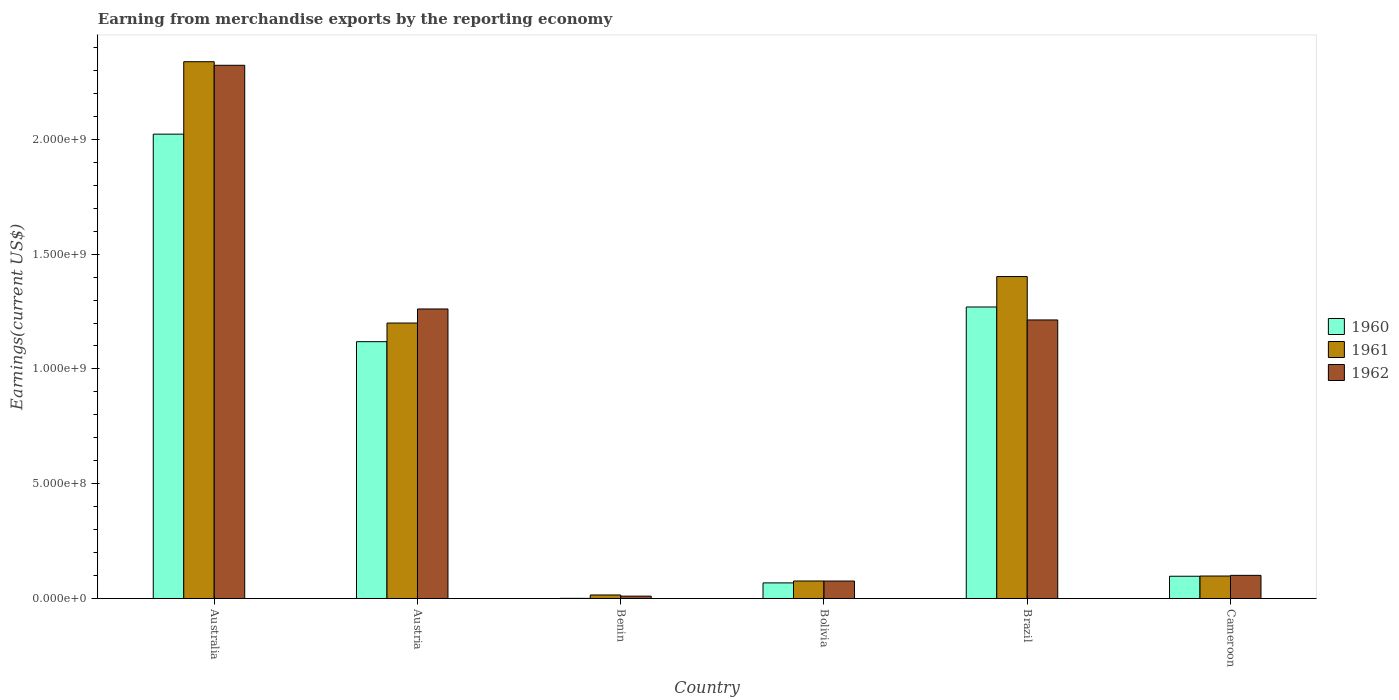How many different coloured bars are there?
Make the answer very short. 3. How many groups of bars are there?
Your answer should be compact. 6. Are the number of bars per tick equal to the number of legend labels?
Give a very brief answer. Yes. How many bars are there on the 5th tick from the left?
Keep it short and to the point. 3. How many bars are there on the 4th tick from the right?
Your answer should be compact. 3. What is the label of the 2nd group of bars from the left?
Your answer should be very brief. Austria. In how many cases, is the number of bars for a given country not equal to the number of legend labels?
Offer a terse response. 0. What is the amount earned from merchandise exports in 1961 in Benin?
Your response must be concise. 1.53e+07. Across all countries, what is the maximum amount earned from merchandise exports in 1962?
Offer a very short reply. 2.32e+09. Across all countries, what is the minimum amount earned from merchandise exports in 1962?
Keep it short and to the point. 1.02e+07. In which country was the amount earned from merchandise exports in 1962 minimum?
Ensure brevity in your answer.  Benin. What is the total amount earned from merchandise exports in 1960 in the graph?
Provide a succinct answer. 4.58e+09. What is the difference between the amount earned from merchandise exports in 1960 in Australia and that in Bolivia?
Your answer should be compact. 1.96e+09. What is the difference between the amount earned from merchandise exports in 1961 in Brazil and the amount earned from merchandise exports in 1960 in Australia?
Offer a very short reply. -6.20e+08. What is the average amount earned from merchandise exports in 1961 per country?
Give a very brief answer. 8.55e+08. What is the difference between the amount earned from merchandise exports of/in 1962 and amount earned from merchandise exports of/in 1960 in Cameroon?
Provide a succinct answer. 3.90e+06. What is the ratio of the amount earned from merchandise exports in 1960 in Benin to that in Brazil?
Your answer should be compact. 0. Is the difference between the amount earned from merchandise exports in 1962 in Austria and Brazil greater than the difference between the amount earned from merchandise exports in 1960 in Austria and Brazil?
Offer a very short reply. Yes. What is the difference between the highest and the second highest amount earned from merchandise exports in 1962?
Your answer should be compact. 1.06e+09. What is the difference between the highest and the lowest amount earned from merchandise exports in 1961?
Ensure brevity in your answer.  2.32e+09. In how many countries, is the amount earned from merchandise exports in 1960 greater than the average amount earned from merchandise exports in 1960 taken over all countries?
Make the answer very short. 3. Is the sum of the amount earned from merchandise exports in 1960 in Austria and Benin greater than the maximum amount earned from merchandise exports in 1962 across all countries?
Ensure brevity in your answer.  No. What does the 1st bar from the left in Bolivia represents?
Your answer should be compact. 1960. Is it the case that in every country, the sum of the amount earned from merchandise exports in 1962 and amount earned from merchandise exports in 1960 is greater than the amount earned from merchandise exports in 1961?
Provide a short and direct response. No. How many bars are there?
Give a very brief answer. 18. How many countries are there in the graph?
Give a very brief answer. 6. What is the difference between two consecutive major ticks on the Y-axis?
Provide a short and direct response. 5.00e+08. What is the title of the graph?
Keep it short and to the point. Earning from merchandise exports by the reporting economy. Does "1995" appear as one of the legend labels in the graph?
Your answer should be compact. No. What is the label or title of the Y-axis?
Your answer should be compact. Earnings(current US$). What is the Earnings(current US$) in 1960 in Australia?
Make the answer very short. 2.02e+09. What is the Earnings(current US$) in 1961 in Australia?
Offer a terse response. 2.34e+09. What is the Earnings(current US$) of 1962 in Australia?
Keep it short and to the point. 2.32e+09. What is the Earnings(current US$) of 1960 in Austria?
Provide a succinct answer. 1.12e+09. What is the Earnings(current US$) of 1961 in Austria?
Provide a short and direct response. 1.20e+09. What is the Earnings(current US$) of 1962 in Austria?
Offer a very short reply. 1.26e+09. What is the Earnings(current US$) in 1961 in Benin?
Make the answer very short. 1.53e+07. What is the Earnings(current US$) of 1962 in Benin?
Make the answer very short. 1.02e+07. What is the Earnings(current US$) in 1960 in Bolivia?
Make the answer very short. 6.79e+07. What is the Earnings(current US$) in 1961 in Bolivia?
Offer a very short reply. 7.62e+07. What is the Earnings(current US$) in 1962 in Bolivia?
Your response must be concise. 7.60e+07. What is the Earnings(current US$) in 1960 in Brazil?
Keep it short and to the point. 1.27e+09. What is the Earnings(current US$) in 1961 in Brazil?
Provide a succinct answer. 1.40e+09. What is the Earnings(current US$) of 1962 in Brazil?
Make the answer very short. 1.21e+09. What is the Earnings(current US$) of 1960 in Cameroon?
Offer a very short reply. 9.69e+07. What is the Earnings(current US$) of 1961 in Cameroon?
Offer a very short reply. 9.79e+07. What is the Earnings(current US$) of 1962 in Cameroon?
Your answer should be compact. 1.01e+08. Across all countries, what is the maximum Earnings(current US$) of 1960?
Offer a terse response. 2.02e+09. Across all countries, what is the maximum Earnings(current US$) of 1961?
Keep it short and to the point. 2.34e+09. Across all countries, what is the maximum Earnings(current US$) of 1962?
Provide a short and direct response. 2.32e+09. Across all countries, what is the minimum Earnings(current US$) of 1960?
Your answer should be compact. 5.00e+05. Across all countries, what is the minimum Earnings(current US$) of 1961?
Offer a terse response. 1.53e+07. Across all countries, what is the minimum Earnings(current US$) in 1962?
Provide a short and direct response. 1.02e+07. What is the total Earnings(current US$) of 1960 in the graph?
Keep it short and to the point. 4.58e+09. What is the total Earnings(current US$) of 1961 in the graph?
Your answer should be very brief. 5.13e+09. What is the total Earnings(current US$) of 1962 in the graph?
Provide a succinct answer. 4.98e+09. What is the difference between the Earnings(current US$) of 1960 in Australia and that in Austria?
Make the answer very short. 9.04e+08. What is the difference between the Earnings(current US$) in 1961 in Australia and that in Austria?
Your answer should be very brief. 1.14e+09. What is the difference between the Earnings(current US$) in 1962 in Australia and that in Austria?
Keep it short and to the point. 1.06e+09. What is the difference between the Earnings(current US$) in 1960 in Australia and that in Benin?
Give a very brief answer. 2.02e+09. What is the difference between the Earnings(current US$) of 1961 in Australia and that in Benin?
Keep it short and to the point. 2.32e+09. What is the difference between the Earnings(current US$) in 1962 in Australia and that in Benin?
Make the answer very short. 2.31e+09. What is the difference between the Earnings(current US$) in 1960 in Australia and that in Bolivia?
Provide a succinct answer. 1.96e+09. What is the difference between the Earnings(current US$) in 1961 in Australia and that in Bolivia?
Your response must be concise. 2.26e+09. What is the difference between the Earnings(current US$) of 1962 in Australia and that in Bolivia?
Offer a very short reply. 2.25e+09. What is the difference between the Earnings(current US$) in 1960 in Australia and that in Brazil?
Make the answer very short. 7.53e+08. What is the difference between the Earnings(current US$) in 1961 in Australia and that in Brazil?
Offer a very short reply. 9.36e+08. What is the difference between the Earnings(current US$) in 1962 in Australia and that in Brazil?
Your answer should be very brief. 1.11e+09. What is the difference between the Earnings(current US$) of 1960 in Australia and that in Cameroon?
Your response must be concise. 1.93e+09. What is the difference between the Earnings(current US$) of 1961 in Australia and that in Cameroon?
Give a very brief answer. 2.24e+09. What is the difference between the Earnings(current US$) in 1962 in Australia and that in Cameroon?
Ensure brevity in your answer.  2.22e+09. What is the difference between the Earnings(current US$) in 1960 in Austria and that in Benin?
Keep it short and to the point. 1.12e+09. What is the difference between the Earnings(current US$) of 1961 in Austria and that in Benin?
Ensure brevity in your answer.  1.18e+09. What is the difference between the Earnings(current US$) in 1962 in Austria and that in Benin?
Your answer should be compact. 1.25e+09. What is the difference between the Earnings(current US$) of 1960 in Austria and that in Bolivia?
Give a very brief answer. 1.05e+09. What is the difference between the Earnings(current US$) of 1961 in Austria and that in Bolivia?
Your response must be concise. 1.12e+09. What is the difference between the Earnings(current US$) in 1962 in Austria and that in Bolivia?
Keep it short and to the point. 1.19e+09. What is the difference between the Earnings(current US$) of 1960 in Austria and that in Brazil?
Provide a succinct answer. -1.51e+08. What is the difference between the Earnings(current US$) of 1961 in Austria and that in Brazil?
Give a very brief answer. -2.02e+08. What is the difference between the Earnings(current US$) of 1962 in Austria and that in Brazil?
Provide a short and direct response. 4.78e+07. What is the difference between the Earnings(current US$) of 1960 in Austria and that in Cameroon?
Your answer should be compact. 1.02e+09. What is the difference between the Earnings(current US$) in 1961 in Austria and that in Cameroon?
Offer a terse response. 1.10e+09. What is the difference between the Earnings(current US$) of 1962 in Austria and that in Cameroon?
Make the answer very short. 1.16e+09. What is the difference between the Earnings(current US$) in 1960 in Benin and that in Bolivia?
Offer a very short reply. -6.74e+07. What is the difference between the Earnings(current US$) of 1961 in Benin and that in Bolivia?
Provide a succinct answer. -6.09e+07. What is the difference between the Earnings(current US$) in 1962 in Benin and that in Bolivia?
Give a very brief answer. -6.58e+07. What is the difference between the Earnings(current US$) in 1960 in Benin and that in Brazil?
Offer a very short reply. -1.27e+09. What is the difference between the Earnings(current US$) of 1961 in Benin and that in Brazil?
Ensure brevity in your answer.  -1.39e+09. What is the difference between the Earnings(current US$) in 1962 in Benin and that in Brazil?
Provide a succinct answer. -1.20e+09. What is the difference between the Earnings(current US$) in 1960 in Benin and that in Cameroon?
Your answer should be compact. -9.64e+07. What is the difference between the Earnings(current US$) of 1961 in Benin and that in Cameroon?
Provide a succinct answer. -8.26e+07. What is the difference between the Earnings(current US$) in 1962 in Benin and that in Cameroon?
Your response must be concise. -9.06e+07. What is the difference between the Earnings(current US$) in 1960 in Bolivia and that in Brazil?
Your answer should be compact. -1.20e+09. What is the difference between the Earnings(current US$) of 1961 in Bolivia and that in Brazil?
Offer a very short reply. -1.33e+09. What is the difference between the Earnings(current US$) in 1962 in Bolivia and that in Brazil?
Keep it short and to the point. -1.14e+09. What is the difference between the Earnings(current US$) of 1960 in Bolivia and that in Cameroon?
Give a very brief answer. -2.90e+07. What is the difference between the Earnings(current US$) of 1961 in Bolivia and that in Cameroon?
Offer a terse response. -2.17e+07. What is the difference between the Earnings(current US$) of 1962 in Bolivia and that in Cameroon?
Ensure brevity in your answer.  -2.48e+07. What is the difference between the Earnings(current US$) in 1960 in Brazil and that in Cameroon?
Provide a succinct answer. 1.17e+09. What is the difference between the Earnings(current US$) of 1961 in Brazil and that in Cameroon?
Ensure brevity in your answer.  1.30e+09. What is the difference between the Earnings(current US$) of 1962 in Brazil and that in Cameroon?
Ensure brevity in your answer.  1.11e+09. What is the difference between the Earnings(current US$) of 1960 in Australia and the Earnings(current US$) of 1961 in Austria?
Your answer should be very brief. 8.23e+08. What is the difference between the Earnings(current US$) in 1960 in Australia and the Earnings(current US$) in 1962 in Austria?
Provide a short and direct response. 7.62e+08. What is the difference between the Earnings(current US$) of 1961 in Australia and the Earnings(current US$) of 1962 in Austria?
Offer a very short reply. 1.08e+09. What is the difference between the Earnings(current US$) of 1960 in Australia and the Earnings(current US$) of 1961 in Benin?
Keep it short and to the point. 2.01e+09. What is the difference between the Earnings(current US$) in 1960 in Australia and the Earnings(current US$) in 1962 in Benin?
Provide a short and direct response. 2.01e+09. What is the difference between the Earnings(current US$) in 1961 in Australia and the Earnings(current US$) in 1962 in Benin?
Provide a succinct answer. 2.33e+09. What is the difference between the Earnings(current US$) in 1960 in Australia and the Earnings(current US$) in 1961 in Bolivia?
Make the answer very short. 1.95e+09. What is the difference between the Earnings(current US$) of 1960 in Australia and the Earnings(current US$) of 1962 in Bolivia?
Your answer should be compact. 1.95e+09. What is the difference between the Earnings(current US$) of 1961 in Australia and the Earnings(current US$) of 1962 in Bolivia?
Provide a short and direct response. 2.26e+09. What is the difference between the Earnings(current US$) of 1960 in Australia and the Earnings(current US$) of 1961 in Brazil?
Make the answer very short. 6.20e+08. What is the difference between the Earnings(current US$) in 1960 in Australia and the Earnings(current US$) in 1962 in Brazil?
Your answer should be compact. 8.09e+08. What is the difference between the Earnings(current US$) in 1961 in Australia and the Earnings(current US$) in 1962 in Brazil?
Provide a short and direct response. 1.12e+09. What is the difference between the Earnings(current US$) of 1960 in Australia and the Earnings(current US$) of 1961 in Cameroon?
Ensure brevity in your answer.  1.92e+09. What is the difference between the Earnings(current US$) in 1960 in Australia and the Earnings(current US$) in 1962 in Cameroon?
Keep it short and to the point. 1.92e+09. What is the difference between the Earnings(current US$) in 1961 in Australia and the Earnings(current US$) in 1962 in Cameroon?
Offer a very short reply. 2.24e+09. What is the difference between the Earnings(current US$) in 1960 in Austria and the Earnings(current US$) in 1961 in Benin?
Provide a short and direct response. 1.10e+09. What is the difference between the Earnings(current US$) of 1960 in Austria and the Earnings(current US$) of 1962 in Benin?
Your response must be concise. 1.11e+09. What is the difference between the Earnings(current US$) of 1961 in Austria and the Earnings(current US$) of 1962 in Benin?
Provide a short and direct response. 1.19e+09. What is the difference between the Earnings(current US$) in 1960 in Austria and the Earnings(current US$) in 1961 in Bolivia?
Offer a very short reply. 1.04e+09. What is the difference between the Earnings(current US$) in 1960 in Austria and the Earnings(current US$) in 1962 in Bolivia?
Ensure brevity in your answer.  1.04e+09. What is the difference between the Earnings(current US$) in 1961 in Austria and the Earnings(current US$) in 1962 in Bolivia?
Make the answer very short. 1.12e+09. What is the difference between the Earnings(current US$) of 1960 in Austria and the Earnings(current US$) of 1961 in Brazil?
Offer a terse response. -2.84e+08. What is the difference between the Earnings(current US$) of 1960 in Austria and the Earnings(current US$) of 1962 in Brazil?
Keep it short and to the point. -9.46e+07. What is the difference between the Earnings(current US$) in 1961 in Austria and the Earnings(current US$) in 1962 in Brazil?
Ensure brevity in your answer.  -1.35e+07. What is the difference between the Earnings(current US$) of 1960 in Austria and the Earnings(current US$) of 1961 in Cameroon?
Your answer should be very brief. 1.02e+09. What is the difference between the Earnings(current US$) in 1960 in Austria and the Earnings(current US$) in 1962 in Cameroon?
Offer a very short reply. 1.02e+09. What is the difference between the Earnings(current US$) of 1961 in Austria and the Earnings(current US$) of 1962 in Cameroon?
Provide a succinct answer. 1.10e+09. What is the difference between the Earnings(current US$) in 1960 in Benin and the Earnings(current US$) in 1961 in Bolivia?
Your response must be concise. -7.57e+07. What is the difference between the Earnings(current US$) in 1960 in Benin and the Earnings(current US$) in 1962 in Bolivia?
Provide a short and direct response. -7.55e+07. What is the difference between the Earnings(current US$) of 1961 in Benin and the Earnings(current US$) of 1962 in Bolivia?
Your response must be concise. -6.07e+07. What is the difference between the Earnings(current US$) in 1960 in Benin and the Earnings(current US$) in 1961 in Brazil?
Ensure brevity in your answer.  -1.40e+09. What is the difference between the Earnings(current US$) of 1960 in Benin and the Earnings(current US$) of 1962 in Brazil?
Provide a succinct answer. -1.21e+09. What is the difference between the Earnings(current US$) of 1961 in Benin and the Earnings(current US$) of 1962 in Brazil?
Provide a succinct answer. -1.20e+09. What is the difference between the Earnings(current US$) of 1960 in Benin and the Earnings(current US$) of 1961 in Cameroon?
Make the answer very short. -9.74e+07. What is the difference between the Earnings(current US$) of 1960 in Benin and the Earnings(current US$) of 1962 in Cameroon?
Give a very brief answer. -1.00e+08. What is the difference between the Earnings(current US$) of 1961 in Benin and the Earnings(current US$) of 1962 in Cameroon?
Keep it short and to the point. -8.55e+07. What is the difference between the Earnings(current US$) of 1960 in Bolivia and the Earnings(current US$) of 1961 in Brazil?
Offer a very short reply. -1.33e+09. What is the difference between the Earnings(current US$) in 1960 in Bolivia and the Earnings(current US$) in 1962 in Brazil?
Your answer should be very brief. -1.15e+09. What is the difference between the Earnings(current US$) in 1961 in Bolivia and the Earnings(current US$) in 1962 in Brazil?
Provide a succinct answer. -1.14e+09. What is the difference between the Earnings(current US$) of 1960 in Bolivia and the Earnings(current US$) of 1961 in Cameroon?
Your response must be concise. -3.00e+07. What is the difference between the Earnings(current US$) in 1960 in Bolivia and the Earnings(current US$) in 1962 in Cameroon?
Your response must be concise. -3.29e+07. What is the difference between the Earnings(current US$) of 1961 in Bolivia and the Earnings(current US$) of 1962 in Cameroon?
Your answer should be very brief. -2.46e+07. What is the difference between the Earnings(current US$) in 1960 in Brazil and the Earnings(current US$) in 1961 in Cameroon?
Provide a succinct answer. 1.17e+09. What is the difference between the Earnings(current US$) in 1960 in Brazil and the Earnings(current US$) in 1962 in Cameroon?
Provide a short and direct response. 1.17e+09. What is the difference between the Earnings(current US$) in 1961 in Brazil and the Earnings(current US$) in 1962 in Cameroon?
Your response must be concise. 1.30e+09. What is the average Earnings(current US$) of 1960 per country?
Your answer should be compact. 7.63e+08. What is the average Earnings(current US$) of 1961 per country?
Your response must be concise. 8.55e+08. What is the average Earnings(current US$) in 1962 per country?
Offer a very short reply. 8.31e+08. What is the difference between the Earnings(current US$) in 1960 and Earnings(current US$) in 1961 in Australia?
Make the answer very short. -3.16e+08. What is the difference between the Earnings(current US$) of 1960 and Earnings(current US$) of 1962 in Australia?
Give a very brief answer. -3.00e+08. What is the difference between the Earnings(current US$) in 1961 and Earnings(current US$) in 1962 in Australia?
Keep it short and to the point. 1.56e+07. What is the difference between the Earnings(current US$) in 1960 and Earnings(current US$) in 1961 in Austria?
Make the answer very short. -8.11e+07. What is the difference between the Earnings(current US$) in 1960 and Earnings(current US$) in 1962 in Austria?
Offer a terse response. -1.42e+08. What is the difference between the Earnings(current US$) in 1961 and Earnings(current US$) in 1962 in Austria?
Keep it short and to the point. -6.13e+07. What is the difference between the Earnings(current US$) in 1960 and Earnings(current US$) in 1961 in Benin?
Provide a short and direct response. -1.48e+07. What is the difference between the Earnings(current US$) in 1960 and Earnings(current US$) in 1962 in Benin?
Give a very brief answer. -9.70e+06. What is the difference between the Earnings(current US$) of 1961 and Earnings(current US$) of 1962 in Benin?
Offer a very short reply. 5.10e+06. What is the difference between the Earnings(current US$) of 1960 and Earnings(current US$) of 1961 in Bolivia?
Your response must be concise. -8.30e+06. What is the difference between the Earnings(current US$) of 1960 and Earnings(current US$) of 1962 in Bolivia?
Provide a short and direct response. -8.10e+06. What is the difference between the Earnings(current US$) of 1960 and Earnings(current US$) of 1961 in Brazil?
Make the answer very short. -1.33e+08. What is the difference between the Earnings(current US$) of 1960 and Earnings(current US$) of 1962 in Brazil?
Make the answer very short. 5.64e+07. What is the difference between the Earnings(current US$) in 1961 and Earnings(current US$) in 1962 in Brazil?
Offer a very short reply. 1.89e+08. What is the difference between the Earnings(current US$) in 1960 and Earnings(current US$) in 1961 in Cameroon?
Keep it short and to the point. -1.00e+06. What is the difference between the Earnings(current US$) of 1960 and Earnings(current US$) of 1962 in Cameroon?
Your answer should be compact. -3.90e+06. What is the difference between the Earnings(current US$) of 1961 and Earnings(current US$) of 1962 in Cameroon?
Your answer should be very brief. -2.90e+06. What is the ratio of the Earnings(current US$) of 1960 in Australia to that in Austria?
Your answer should be compact. 1.81. What is the ratio of the Earnings(current US$) in 1961 in Australia to that in Austria?
Ensure brevity in your answer.  1.95. What is the ratio of the Earnings(current US$) in 1962 in Australia to that in Austria?
Provide a succinct answer. 1.84. What is the ratio of the Earnings(current US$) in 1960 in Australia to that in Benin?
Ensure brevity in your answer.  4045.8. What is the ratio of the Earnings(current US$) of 1961 in Australia to that in Benin?
Keep it short and to the point. 152.84. What is the ratio of the Earnings(current US$) of 1962 in Australia to that in Benin?
Provide a succinct answer. 227.74. What is the ratio of the Earnings(current US$) in 1960 in Australia to that in Bolivia?
Offer a very short reply. 29.79. What is the ratio of the Earnings(current US$) in 1961 in Australia to that in Bolivia?
Your response must be concise. 30.69. What is the ratio of the Earnings(current US$) in 1962 in Australia to that in Bolivia?
Ensure brevity in your answer.  30.56. What is the ratio of the Earnings(current US$) in 1960 in Australia to that in Brazil?
Provide a succinct answer. 1.59. What is the ratio of the Earnings(current US$) of 1961 in Australia to that in Brazil?
Provide a short and direct response. 1.67. What is the ratio of the Earnings(current US$) of 1962 in Australia to that in Brazil?
Offer a terse response. 1.91. What is the ratio of the Earnings(current US$) in 1960 in Australia to that in Cameroon?
Make the answer very short. 20.88. What is the ratio of the Earnings(current US$) in 1961 in Australia to that in Cameroon?
Offer a very short reply. 23.89. What is the ratio of the Earnings(current US$) in 1962 in Australia to that in Cameroon?
Make the answer very short. 23.04. What is the ratio of the Earnings(current US$) in 1960 in Austria to that in Benin?
Provide a succinct answer. 2237.8. What is the ratio of the Earnings(current US$) of 1961 in Austria to that in Benin?
Your response must be concise. 78.43. What is the ratio of the Earnings(current US$) of 1962 in Austria to that in Benin?
Your response must be concise. 123.66. What is the ratio of the Earnings(current US$) in 1960 in Austria to that in Bolivia?
Offer a terse response. 16.48. What is the ratio of the Earnings(current US$) of 1961 in Austria to that in Bolivia?
Keep it short and to the point. 15.75. What is the ratio of the Earnings(current US$) of 1962 in Austria to that in Bolivia?
Make the answer very short. 16.6. What is the ratio of the Earnings(current US$) in 1960 in Austria to that in Brazil?
Provide a succinct answer. 0.88. What is the ratio of the Earnings(current US$) of 1961 in Austria to that in Brazil?
Your answer should be very brief. 0.86. What is the ratio of the Earnings(current US$) of 1962 in Austria to that in Brazil?
Your answer should be very brief. 1.04. What is the ratio of the Earnings(current US$) of 1960 in Austria to that in Cameroon?
Your answer should be compact. 11.55. What is the ratio of the Earnings(current US$) in 1961 in Austria to that in Cameroon?
Offer a very short reply. 12.26. What is the ratio of the Earnings(current US$) of 1962 in Austria to that in Cameroon?
Offer a very short reply. 12.51. What is the ratio of the Earnings(current US$) in 1960 in Benin to that in Bolivia?
Make the answer very short. 0.01. What is the ratio of the Earnings(current US$) in 1961 in Benin to that in Bolivia?
Your response must be concise. 0.2. What is the ratio of the Earnings(current US$) of 1962 in Benin to that in Bolivia?
Keep it short and to the point. 0.13. What is the ratio of the Earnings(current US$) of 1960 in Benin to that in Brazil?
Your answer should be compact. 0. What is the ratio of the Earnings(current US$) of 1961 in Benin to that in Brazil?
Give a very brief answer. 0.01. What is the ratio of the Earnings(current US$) of 1962 in Benin to that in Brazil?
Your answer should be compact. 0.01. What is the ratio of the Earnings(current US$) of 1960 in Benin to that in Cameroon?
Give a very brief answer. 0.01. What is the ratio of the Earnings(current US$) of 1961 in Benin to that in Cameroon?
Make the answer very short. 0.16. What is the ratio of the Earnings(current US$) of 1962 in Benin to that in Cameroon?
Provide a short and direct response. 0.1. What is the ratio of the Earnings(current US$) in 1960 in Bolivia to that in Brazil?
Your response must be concise. 0.05. What is the ratio of the Earnings(current US$) of 1961 in Bolivia to that in Brazil?
Make the answer very short. 0.05. What is the ratio of the Earnings(current US$) of 1962 in Bolivia to that in Brazil?
Your response must be concise. 0.06. What is the ratio of the Earnings(current US$) of 1960 in Bolivia to that in Cameroon?
Ensure brevity in your answer.  0.7. What is the ratio of the Earnings(current US$) of 1961 in Bolivia to that in Cameroon?
Your response must be concise. 0.78. What is the ratio of the Earnings(current US$) in 1962 in Bolivia to that in Cameroon?
Offer a terse response. 0.75. What is the ratio of the Earnings(current US$) in 1960 in Brazil to that in Cameroon?
Your answer should be compact. 13.11. What is the ratio of the Earnings(current US$) of 1961 in Brazil to that in Cameroon?
Your answer should be compact. 14.33. What is the ratio of the Earnings(current US$) of 1962 in Brazil to that in Cameroon?
Offer a very short reply. 12.04. What is the difference between the highest and the second highest Earnings(current US$) of 1960?
Make the answer very short. 7.53e+08. What is the difference between the highest and the second highest Earnings(current US$) in 1961?
Provide a short and direct response. 9.36e+08. What is the difference between the highest and the second highest Earnings(current US$) in 1962?
Provide a succinct answer. 1.06e+09. What is the difference between the highest and the lowest Earnings(current US$) of 1960?
Offer a very short reply. 2.02e+09. What is the difference between the highest and the lowest Earnings(current US$) in 1961?
Your response must be concise. 2.32e+09. What is the difference between the highest and the lowest Earnings(current US$) in 1962?
Your answer should be compact. 2.31e+09. 